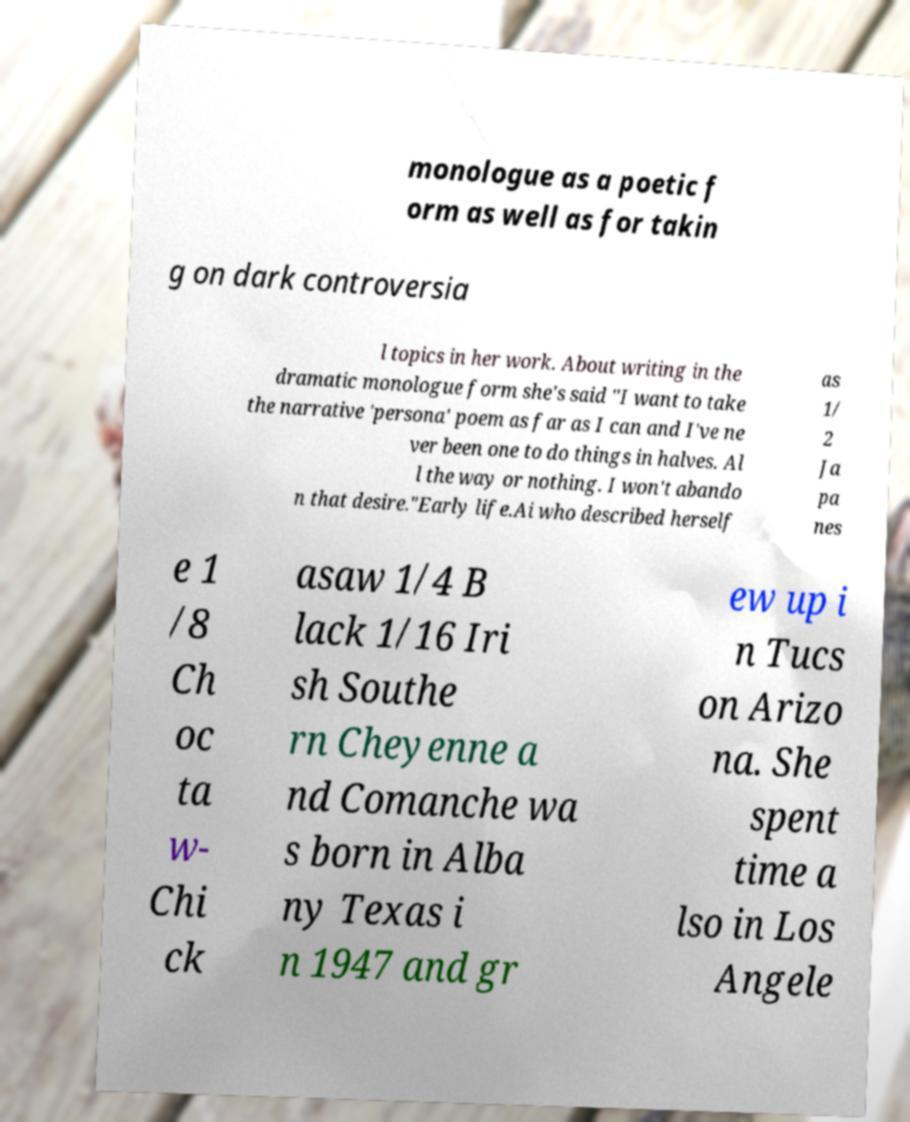Can you read and provide the text displayed in the image?This photo seems to have some interesting text. Can you extract and type it out for me? monologue as a poetic f orm as well as for takin g on dark controversia l topics in her work. About writing in the dramatic monologue form she's said "I want to take the narrative 'persona' poem as far as I can and I've ne ver been one to do things in halves. Al l the way or nothing. I won't abando n that desire."Early life.Ai who described herself as 1/ 2 Ja pa nes e 1 /8 Ch oc ta w- Chi ck asaw 1/4 B lack 1/16 Iri sh Southe rn Cheyenne a nd Comanche wa s born in Alba ny Texas i n 1947 and gr ew up i n Tucs on Arizo na. She spent time a lso in Los Angele 